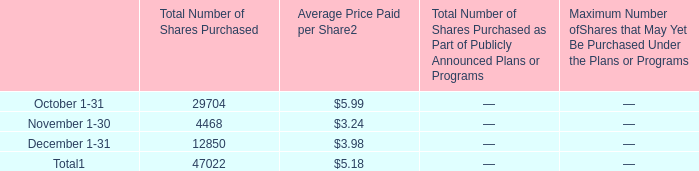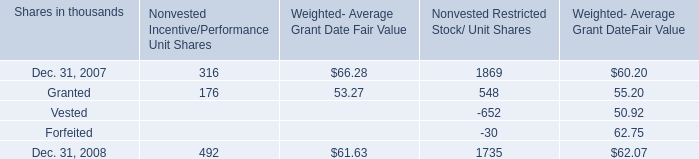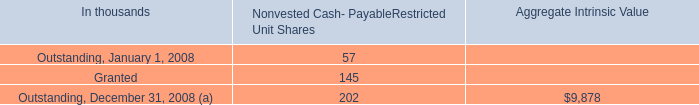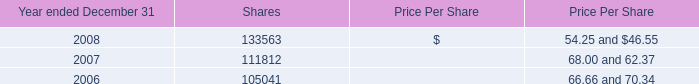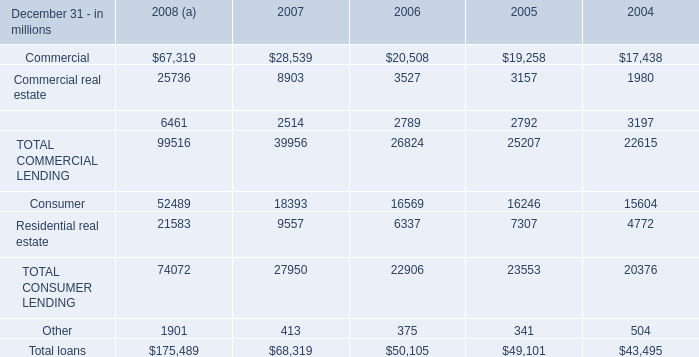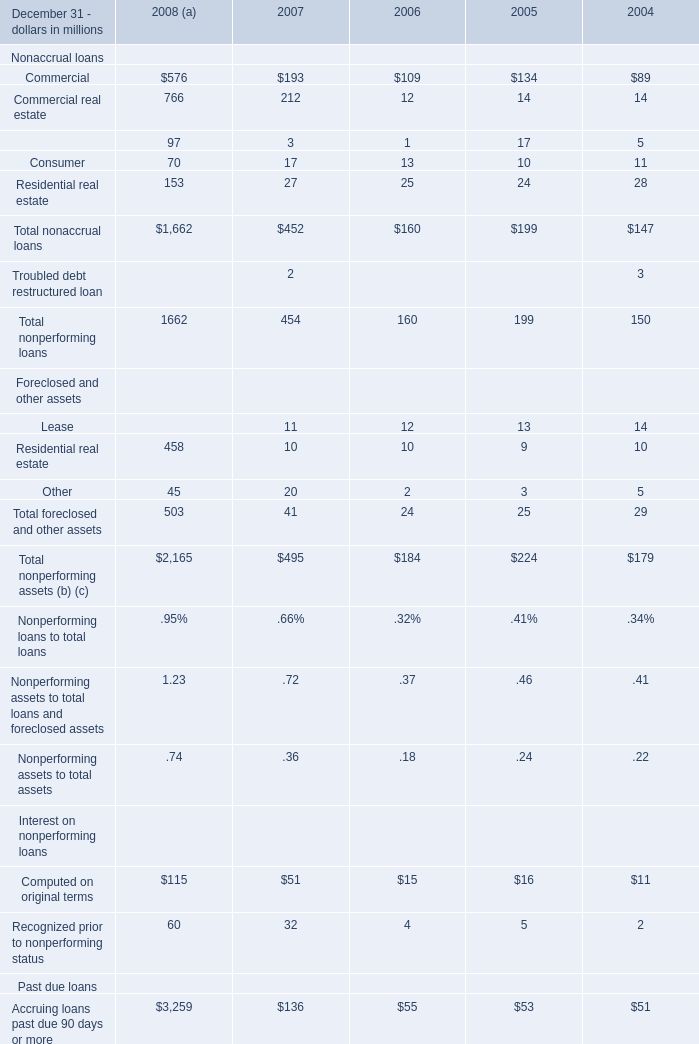In the year with largest amount of Commercial real estate, what's the increasing rate of Consumer? (in %) 
Computations: ((52489 - 18393) / 18393)
Answer: 1.85375. 